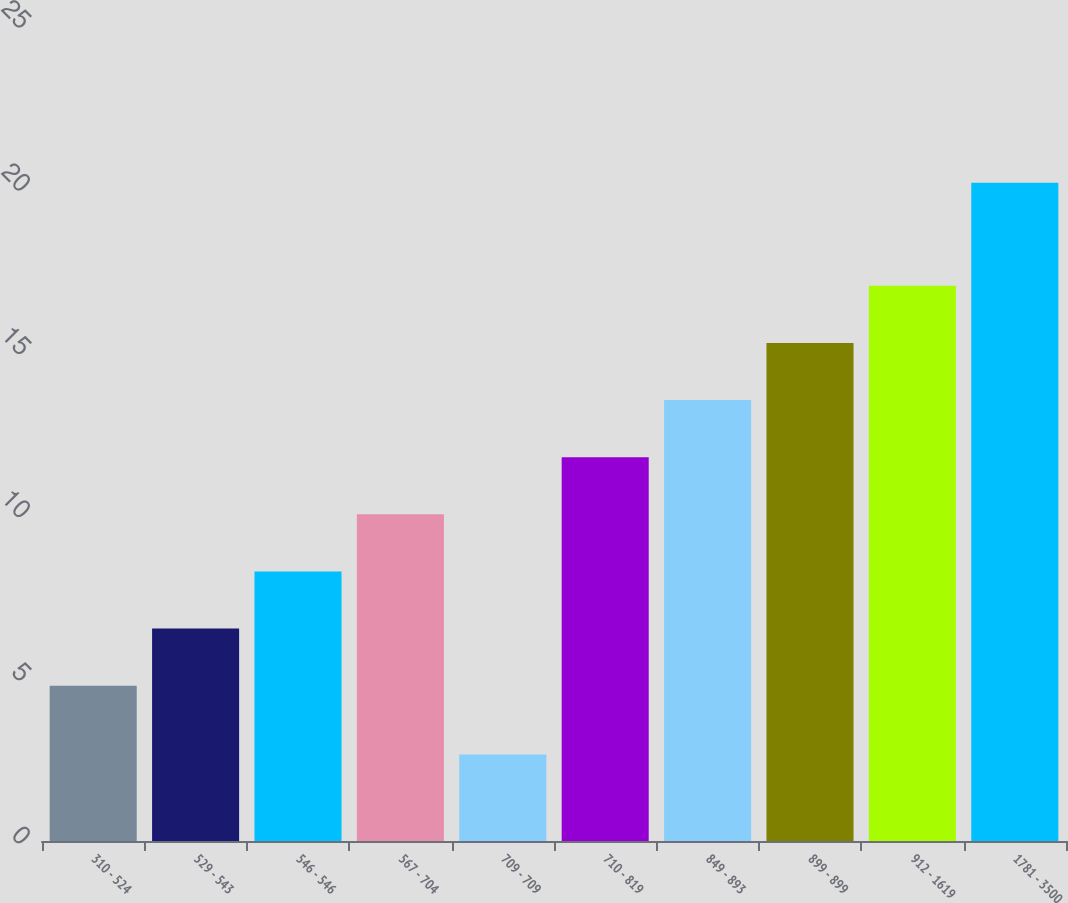Convert chart. <chart><loc_0><loc_0><loc_500><loc_500><bar_chart><fcel>310 - 524<fcel>529 - 543<fcel>546 - 546<fcel>567 - 704<fcel>709 - 709<fcel>710 - 819<fcel>849 - 893<fcel>899 - 899<fcel>912 - 1619<fcel>1781 - 3500<nl><fcel>4.76<fcel>6.51<fcel>8.26<fcel>10.01<fcel>2.65<fcel>11.76<fcel>13.51<fcel>15.26<fcel>17.01<fcel>20.17<nl></chart> 